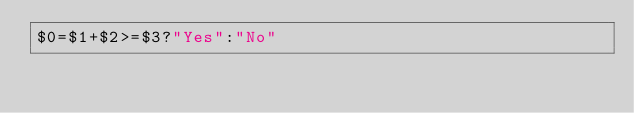<code> <loc_0><loc_0><loc_500><loc_500><_Awk_>$0=$1+$2>=$3?"Yes":"No"</code> 